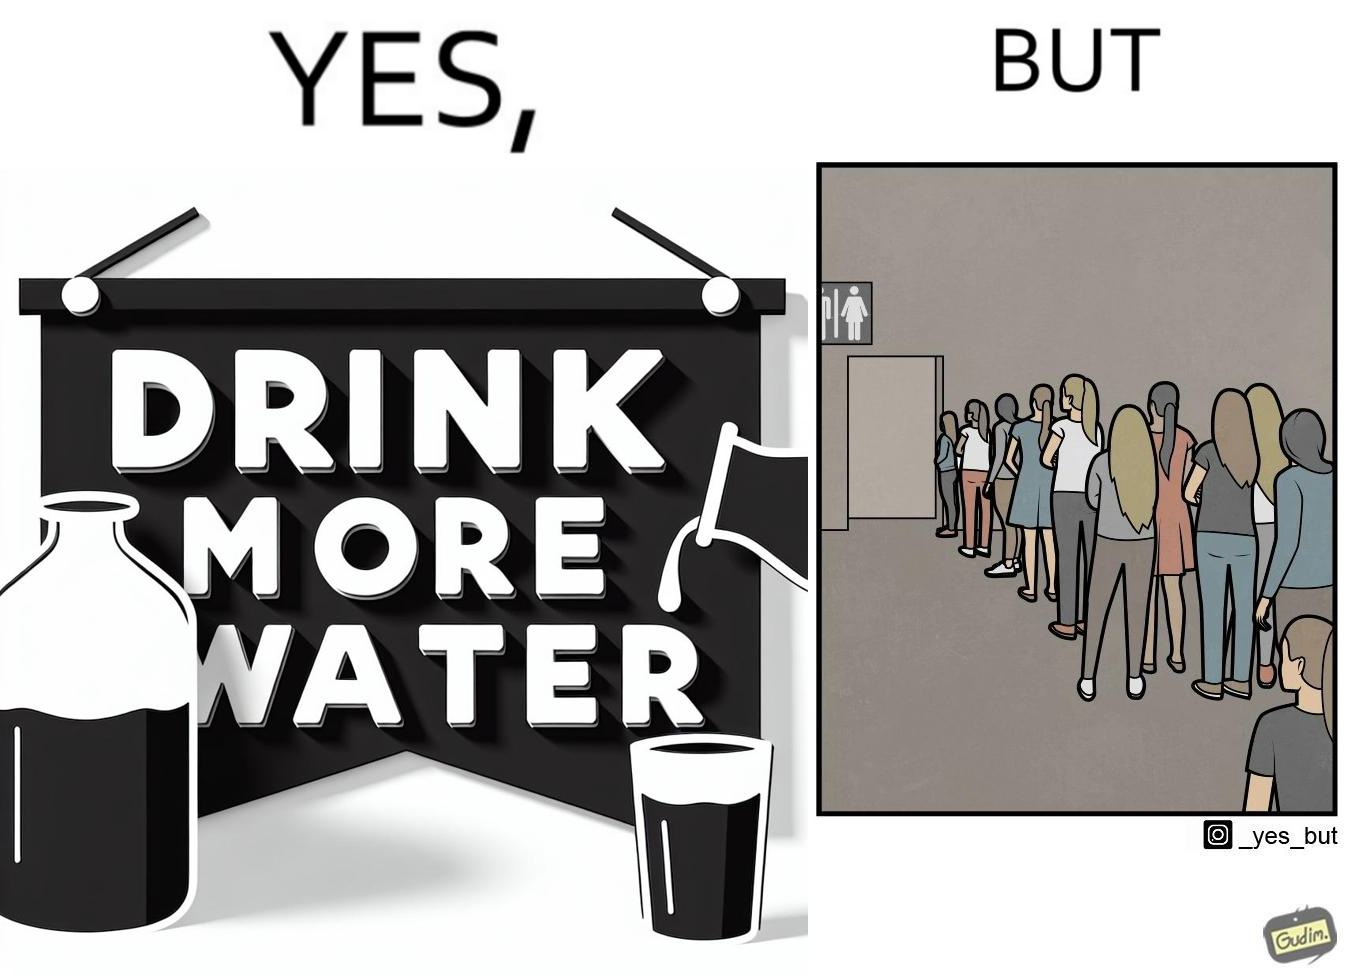Compare the left and right sides of this image. In the left part of the image: A banner that says "Drink more water" with an image of a jug pouring water into a glass. In the right part of the image: a very long queue in front of the public toilet 